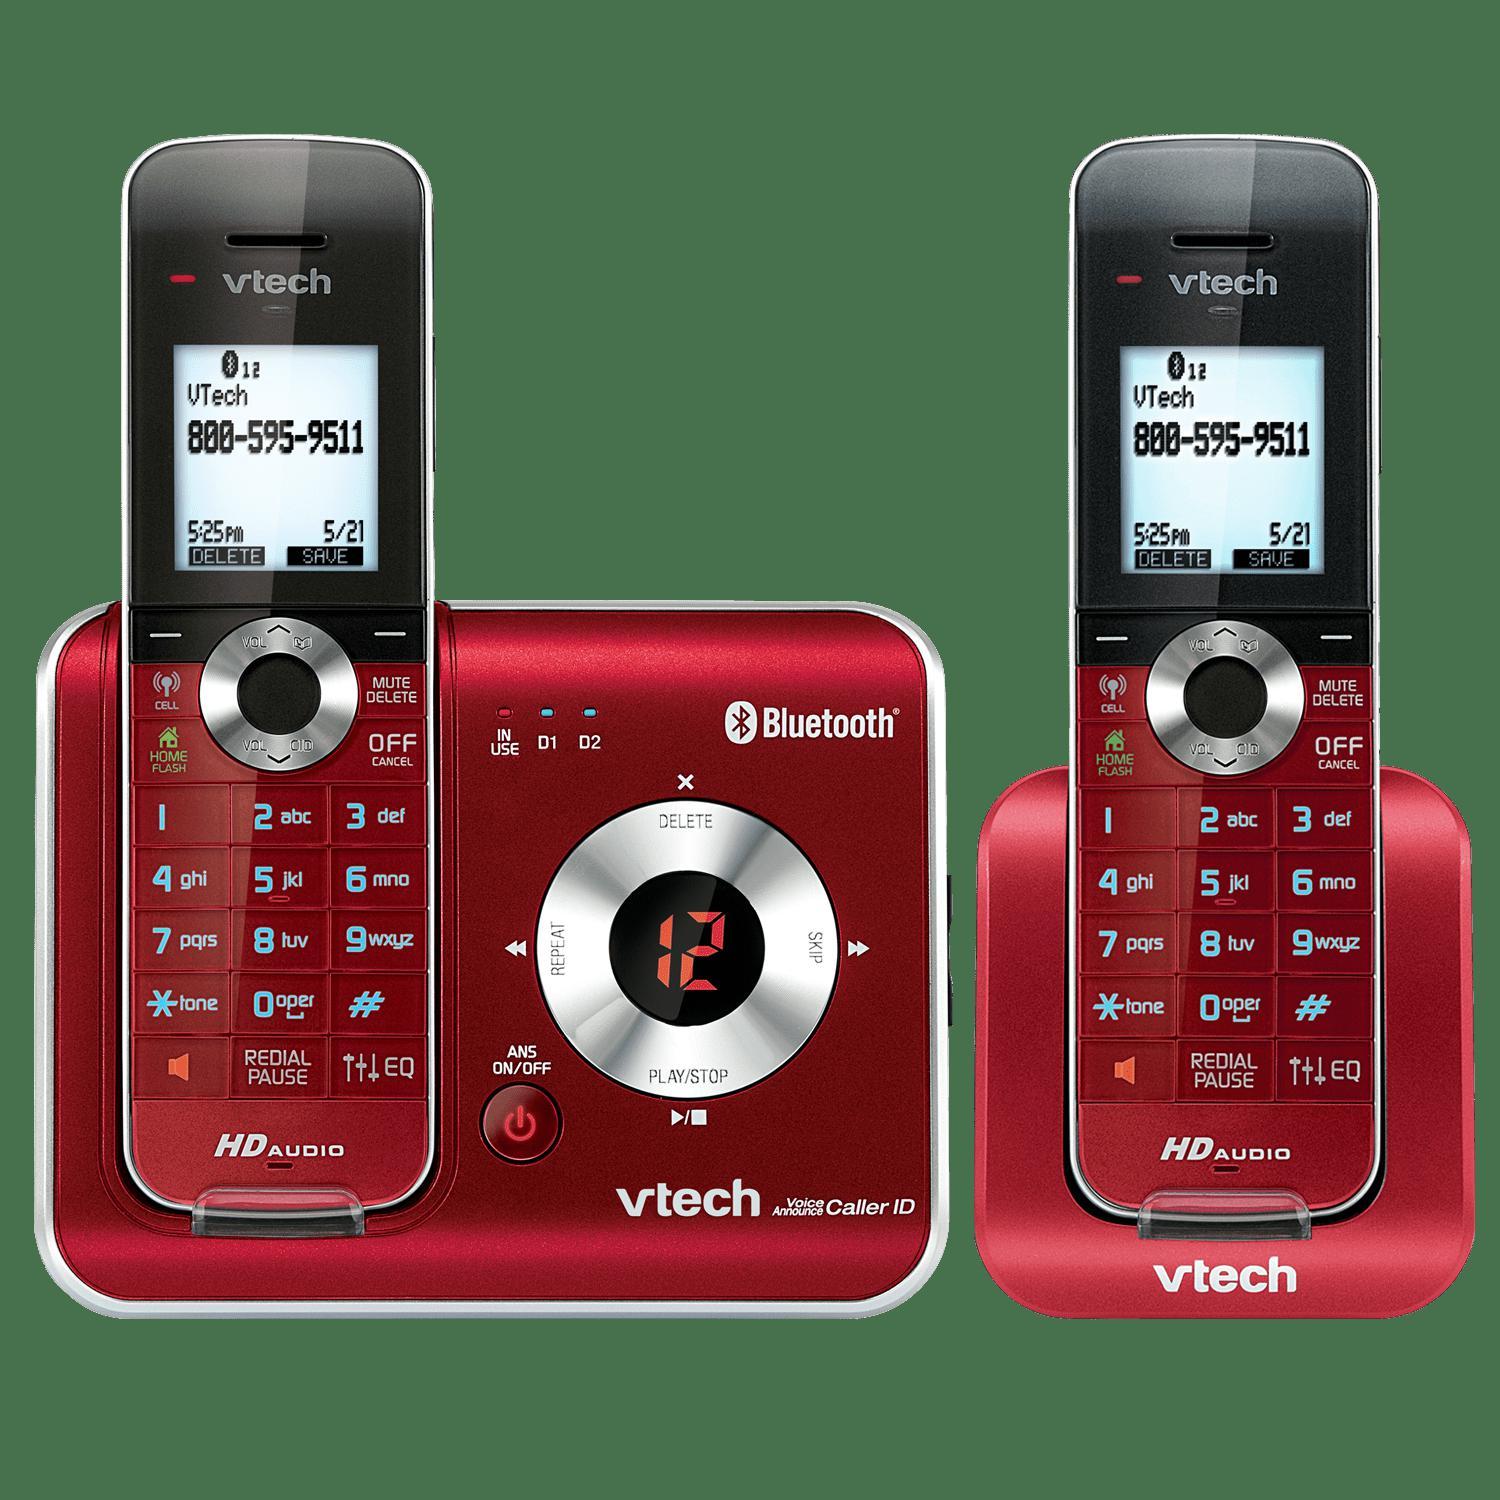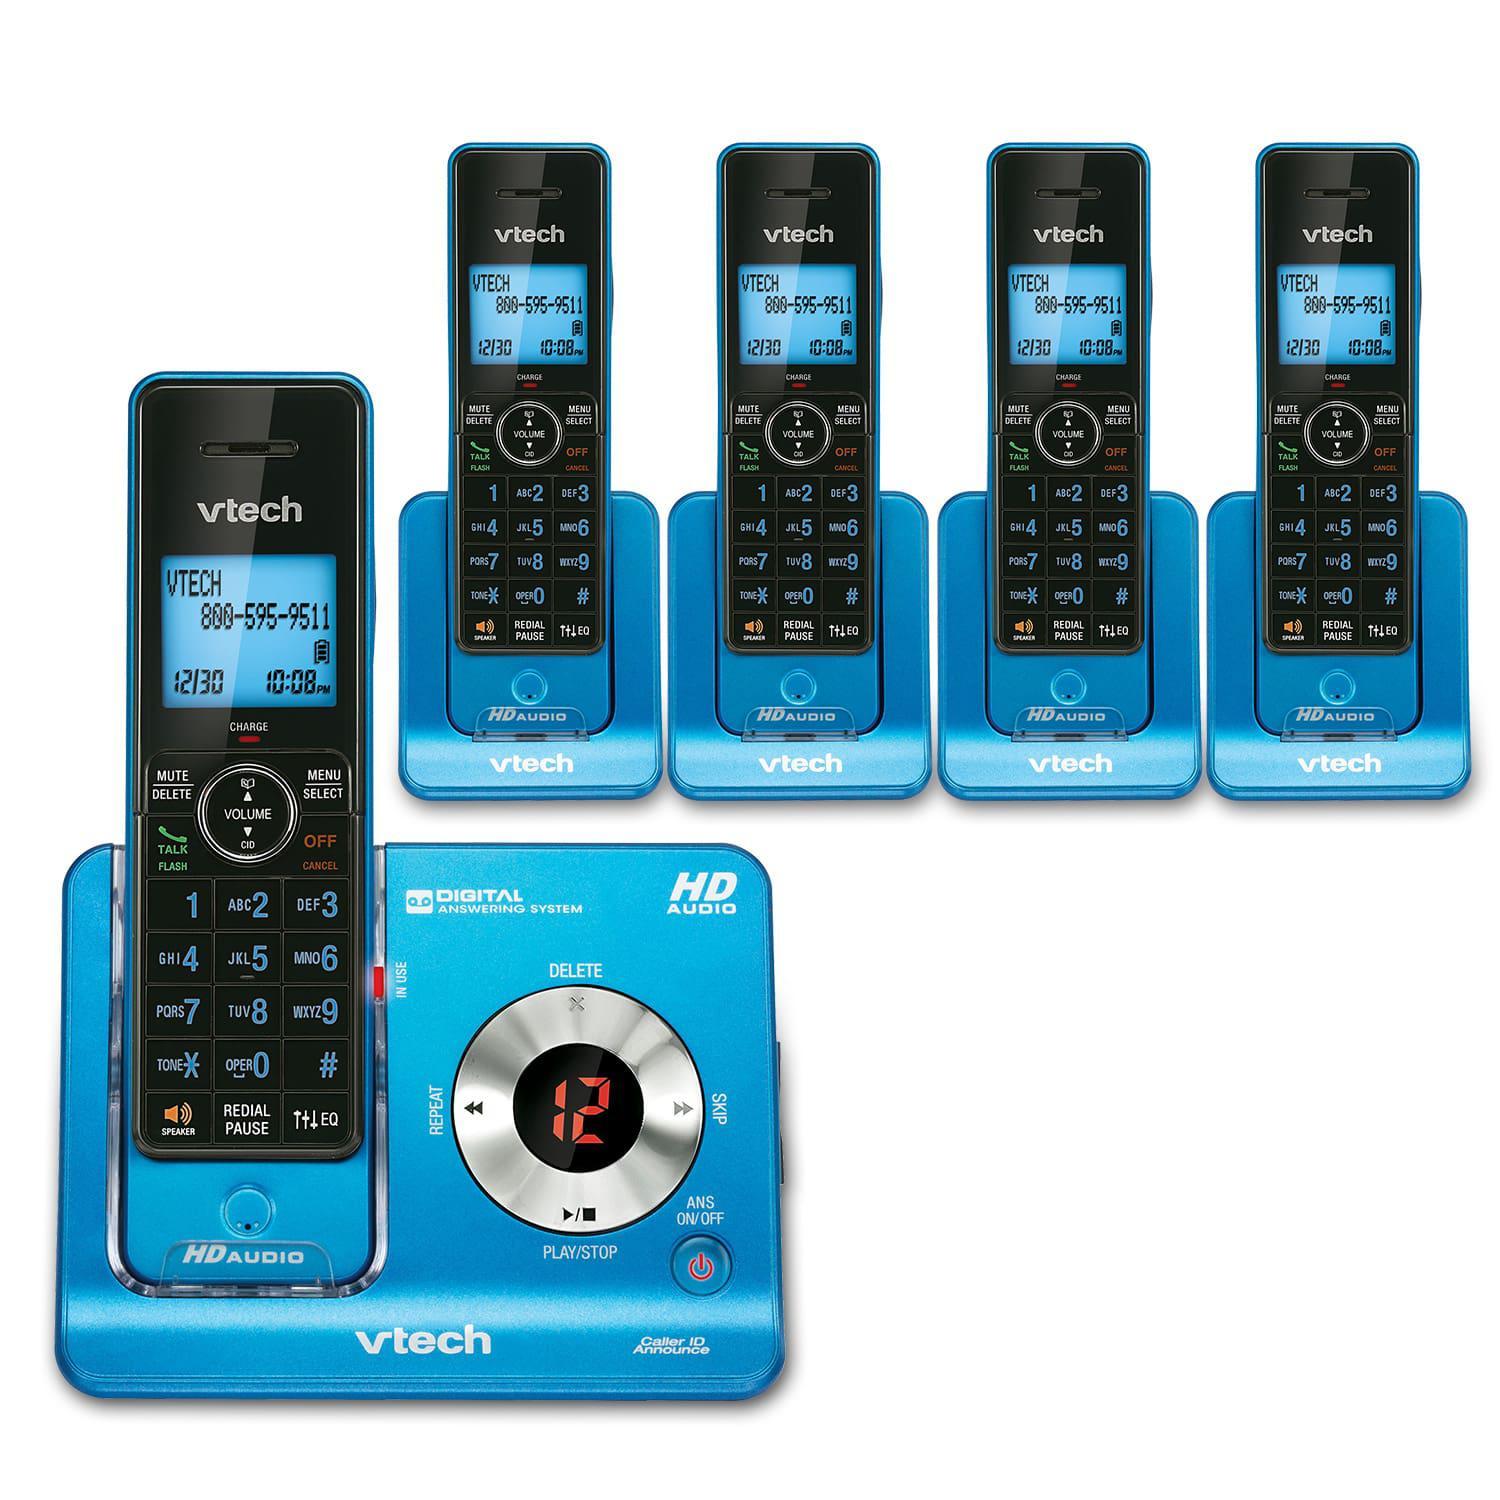The first image is the image on the left, the second image is the image on the right. For the images shown, is this caption "Ninety or fewer physical buttons are visible." true? Answer yes or no. No. The first image is the image on the left, the second image is the image on the right. For the images displayed, is the sentence "One of the images shows the side profile of a phone." factually correct? Answer yes or no. No. 